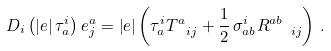Convert formula to latex. <formula><loc_0><loc_0><loc_500><loc_500>D _ { i } \left ( \left | e \right | \tau _ { a } ^ { i } \right ) e _ { j } ^ { a } = \left | e \right | \left ( \tau _ { a } ^ { i } T _ { \ i j } ^ { a } + \frac { 1 } { 2 } \, \sigma _ { a b } ^ { i } R _ { \ \ i j } ^ { a b } \right ) \, .</formula> 